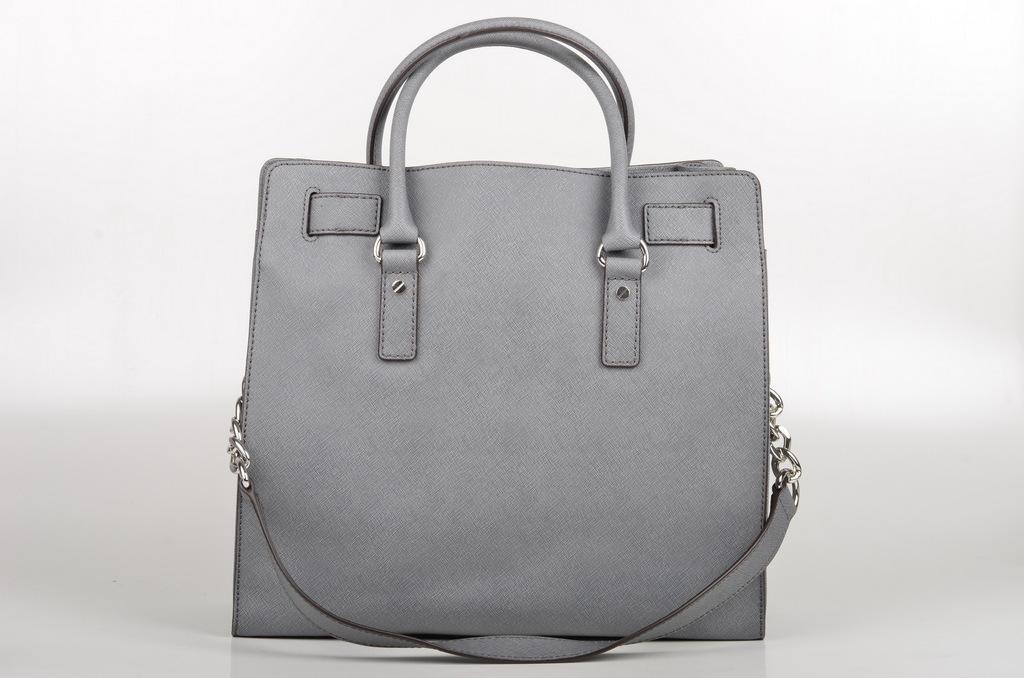Please provide a concise description of this image. This is a picture of a handbag. It is in the center of the picture. Background is white. 